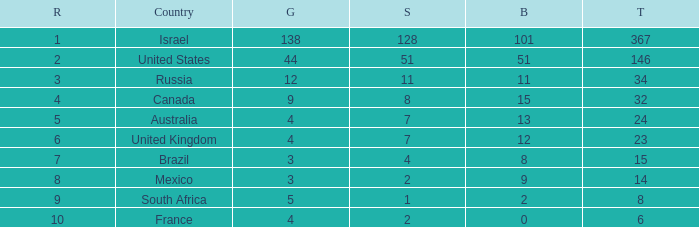What is the maximum number of silvers for a country with fewer than 12 golds and a total less than 8? 2.0. 